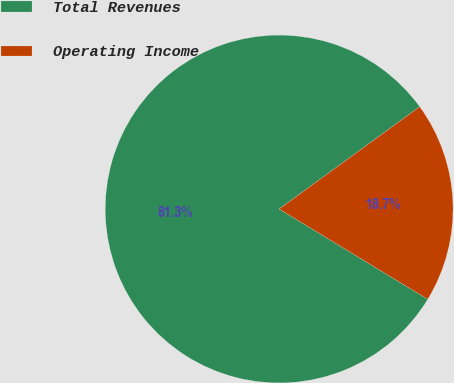Convert chart. <chart><loc_0><loc_0><loc_500><loc_500><pie_chart><fcel>Total Revenues<fcel>Operating Income<nl><fcel>81.3%<fcel>18.7%<nl></chart> 